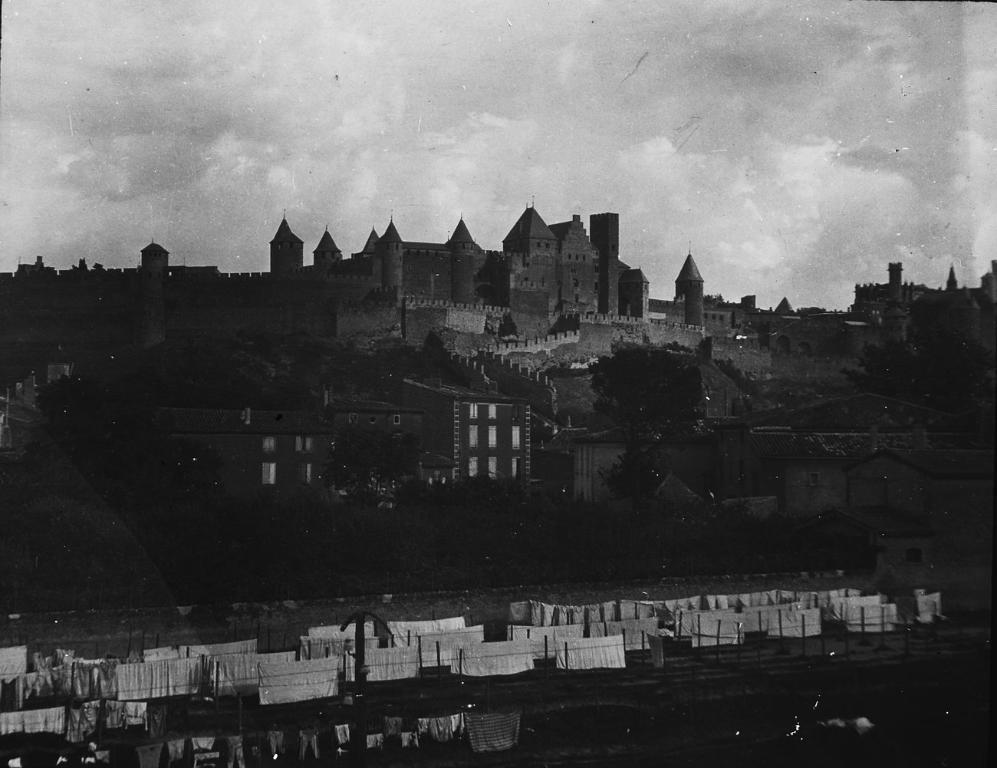How would you summarize this image in a sentence or two? In this image I can see there is a fort and there are few buildings, trees and this is a black and white image and the sky is clear. 